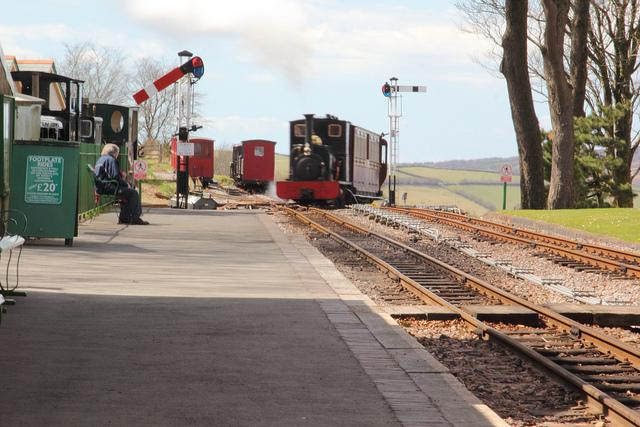What type facility is shown? train station 